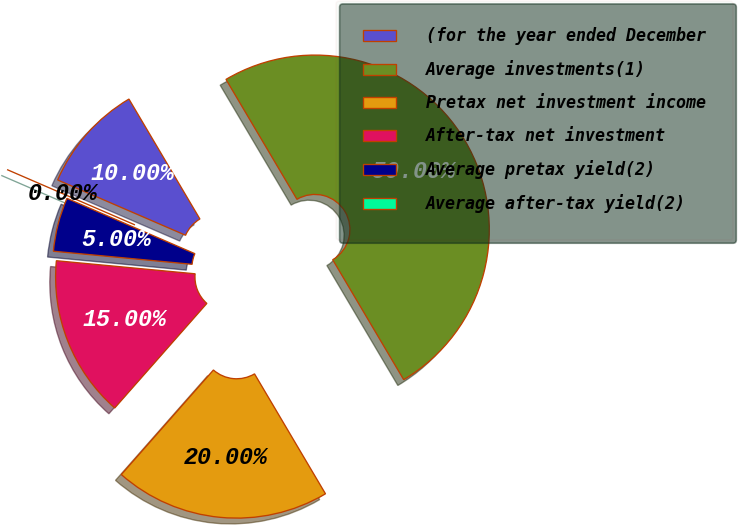Convert chart. <chart><loc_0><loc_0><loc_500><loc_500><pie_chart><fcel>(for the year ended December<fcel>Average investments(1)<fcel>Pretax net investment income<fcel>After-tax net investment<fcel>Average pretax yield(2)<fcel>Average after-tax yield(2)<nl><fcel>10.0%<fcel>50.0%<fcel>20.0%<fcel>15.0%<fcel>5.0%<fcel>0.0%<nl></chart> 